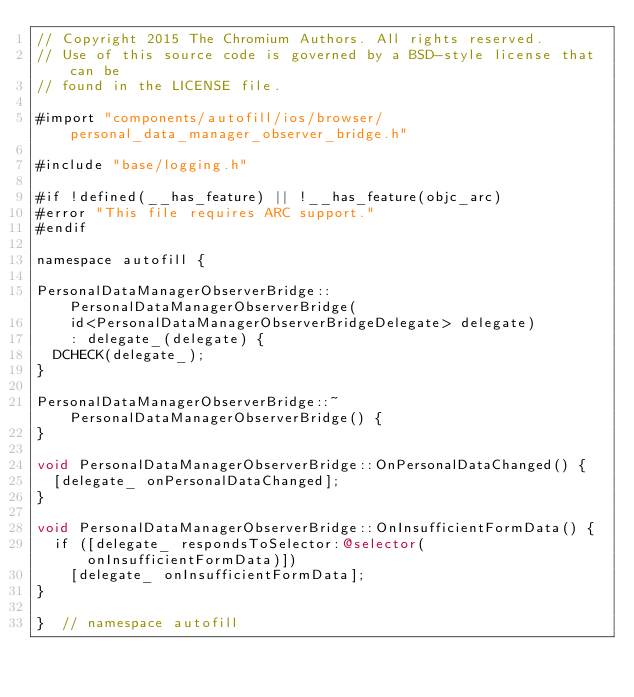Convert code to text. <code><loc_0><loc_0><loc_500><loc_500><_ObjectiveC_>// Copyright 2015 The Chromium Authors. All rights reserved.
// Use of this source code is governed by a BSD-style license that can be
// found in the LICENSE file.

#import "components/autofill/ios/browser/personal_data_manager_observer_bridge.h"

#include "base/logging.h"

#if !defined(__has_feature) || !__has_feature(objc_arc)
#error "This file requires ARC support."
#endif

namespace autofill {

PersonalDataManagerObserverBridge::PersonalDataManagerObserverBridge(
    id<PersonalDataManagerObserverBridgeDelegate> delegate)
    : delegate_(delegate) {
  DCHECK(delegate_);
}

PersonalDataManagerObserverBridge::~PersonalDataManagerObserverBridge() {
}

void PersonalDataManagerObserverBridge::OnPersonalDataChanged() {
  [delegate_ onPersonalDataChanged];
}

void PersonalDataManagerObserverBridge::OnInsufficientFormData() {
  if ([delegate_ respondsToSelector:@selector(onInsufficientFormData)])
    [delegate_ onInsufficientFormData];
}

}  // namespace autofill
</code> 